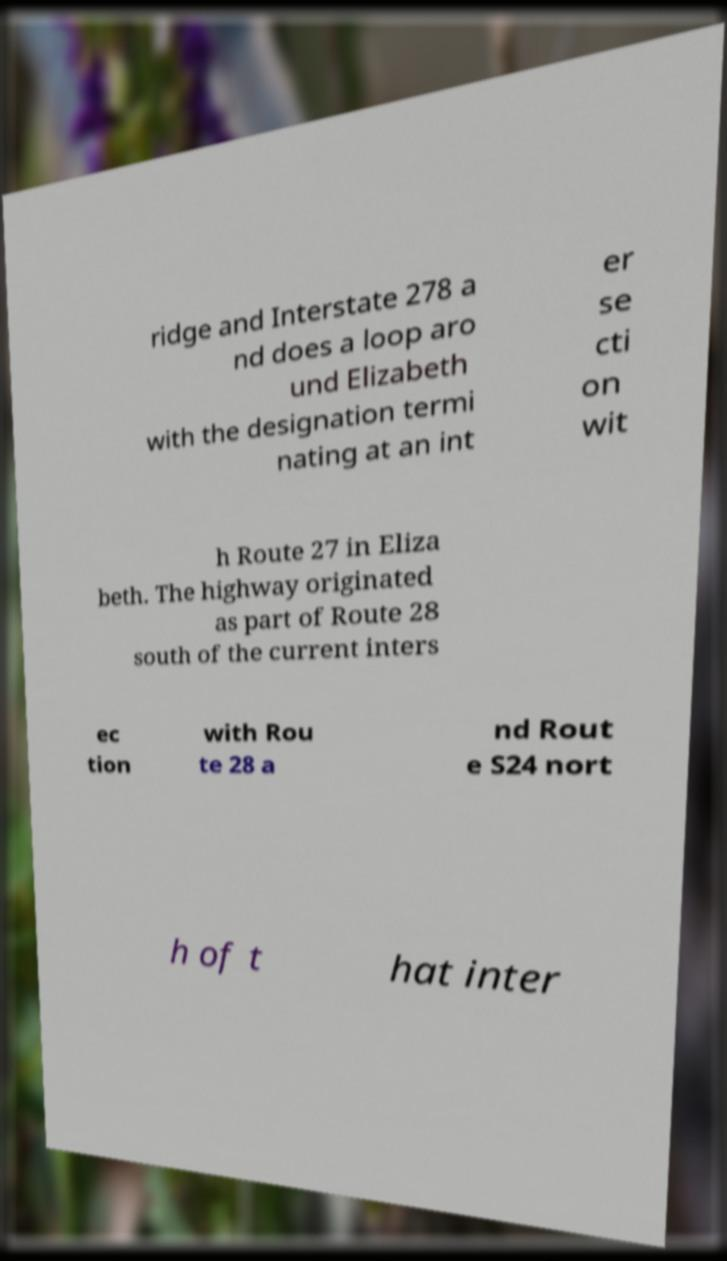What messages or text are displayed in this image? I need them in a readable, typed format. ridge and Interstate 278 a nd does a loop aro und Elizabeth with the designation termi nating at an int er se cti on wit h Route 27 in Eliza beth. The highway originated as part of Route 28 south of the current inters ec tion with Rou te 28 a nd Rout e S24 nort h of t hat inter 